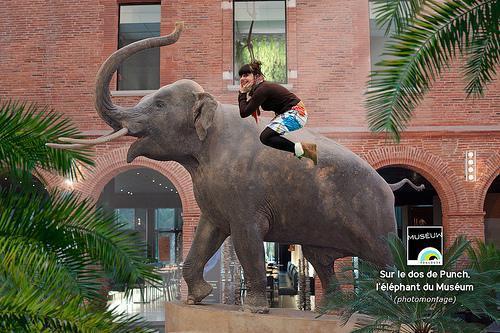How many elephants are there?
Give a very brief answer. 1. 